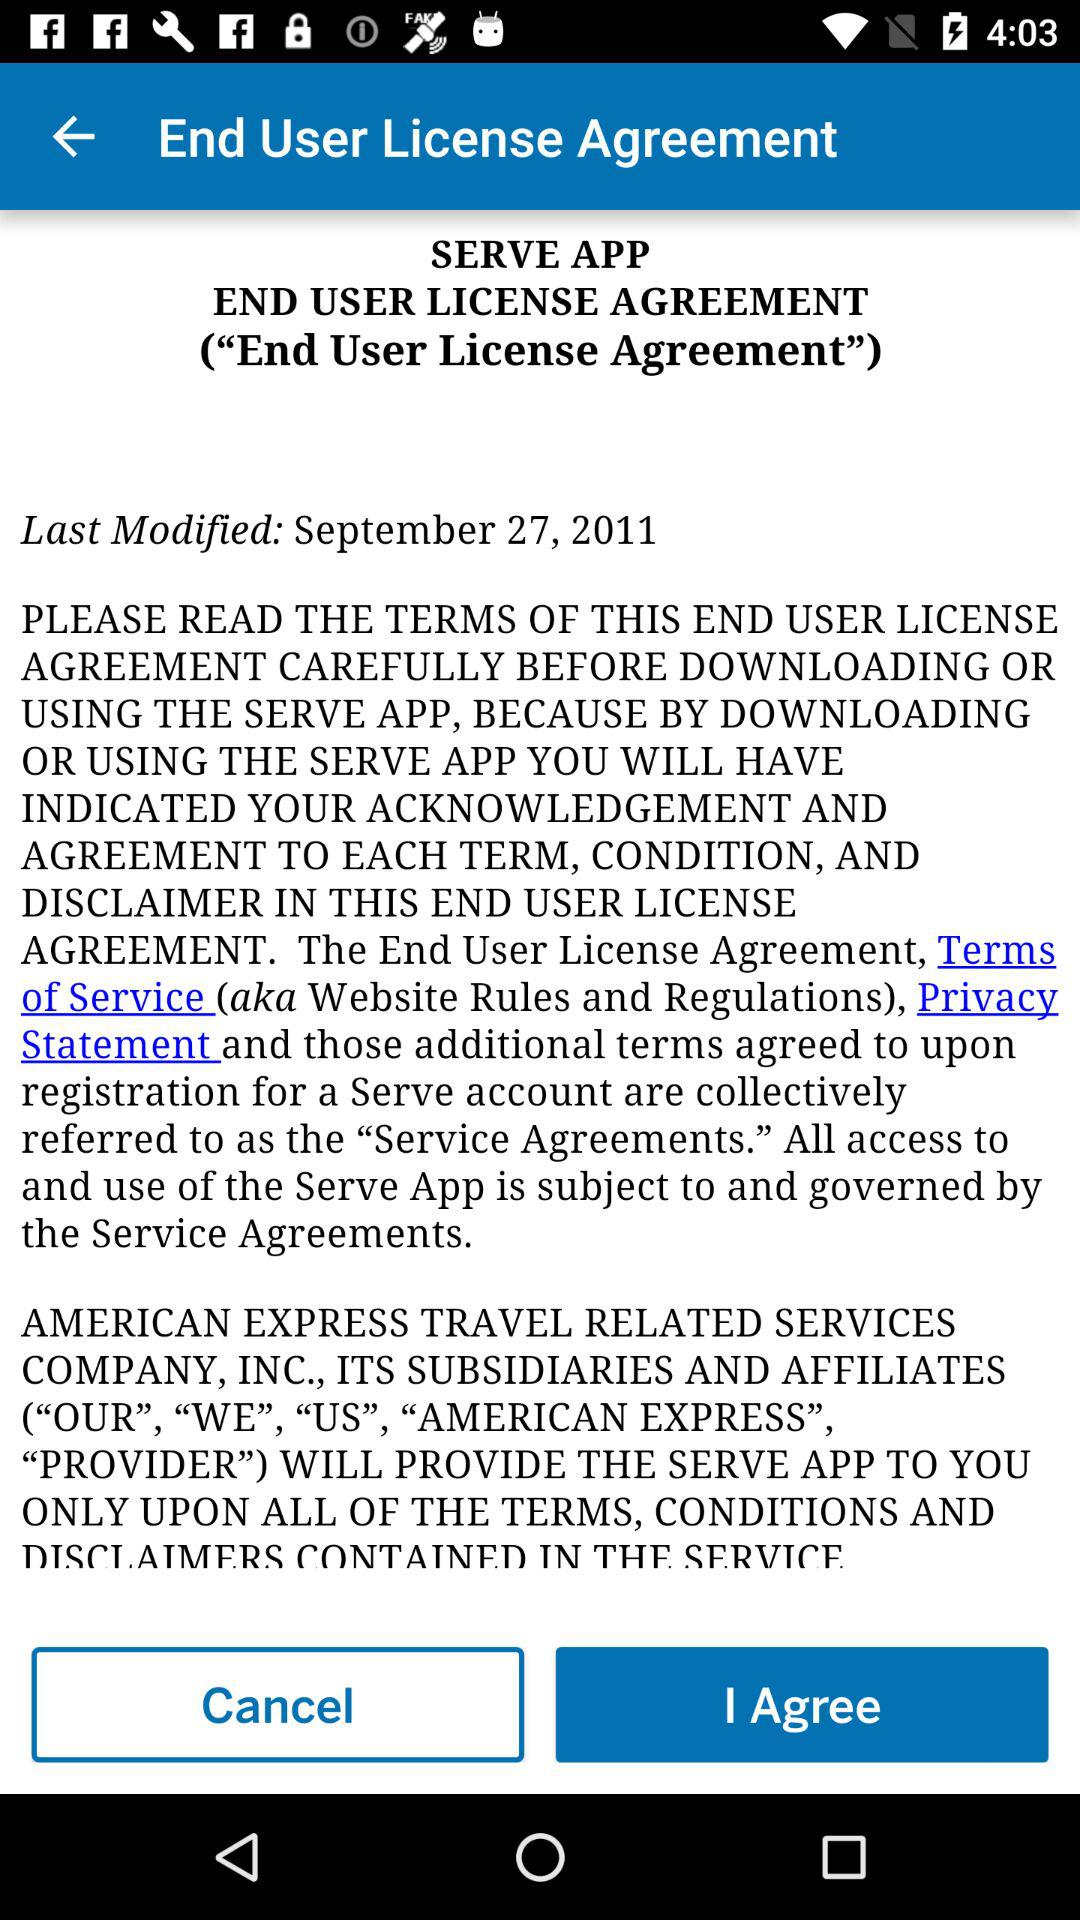On what date was the "End User License Agreement" last modified? The "End User License Agreement" was last modified on September 27, 2011. 